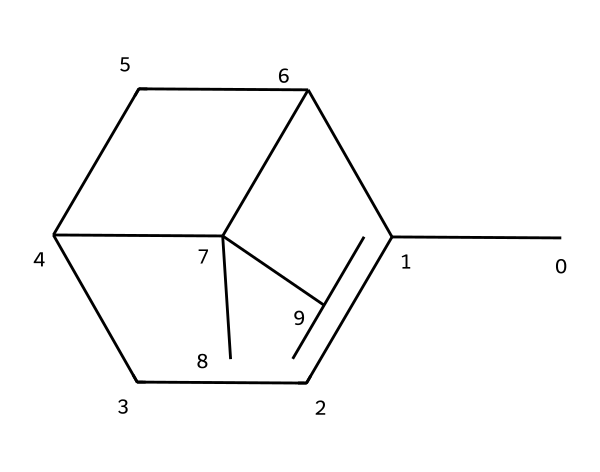What is the molecular formula of pinene? To determine the molecular formula, we count the number of carbon (C) and hydrogen (H) atoms in the structure represented by the SMILES. In the given structure, there are 10 carbon atoms and 16 hydrogen atoms. Therefore, the molecular formula can be represented as C10H16.
Answer: C10H16 How many rings are present in the pinene structure? By analyzing the structure, we observe that there are two ring structures within the molecule. This is indicated by the presence of two cyclohexane-like rings connected to the main carbon chain.
Answer: 2 Is pinene a saturated or unsaturated hydrocarbon? Pinene has double bonds present in its structure, which means it contains regions where carbon atoms are bonded by more than one bond. Such characteristics classify it as an unsaturated hydrocarbon.
Answer: unsaturated What type of terpene is pinene classified as? Pinene is classified as a bicyclic monoterpene because it consists of two connected rings and contains ten carbon atoms in total, characteristic of monoterpenes.
Answer: bicyclic monoterpene How many hydrogen atoms are directly attached to the bridgehead carbons in pinene? In the structure, bridgehead carbons are the two carbon atoms forming part of both rings. Observing the structure, we see that each bridgehead carbon is attached to one hydrogen atom. Thus, there are two hydrogen atoms in total attached to these bridgehead carbons.
Answer: 2 